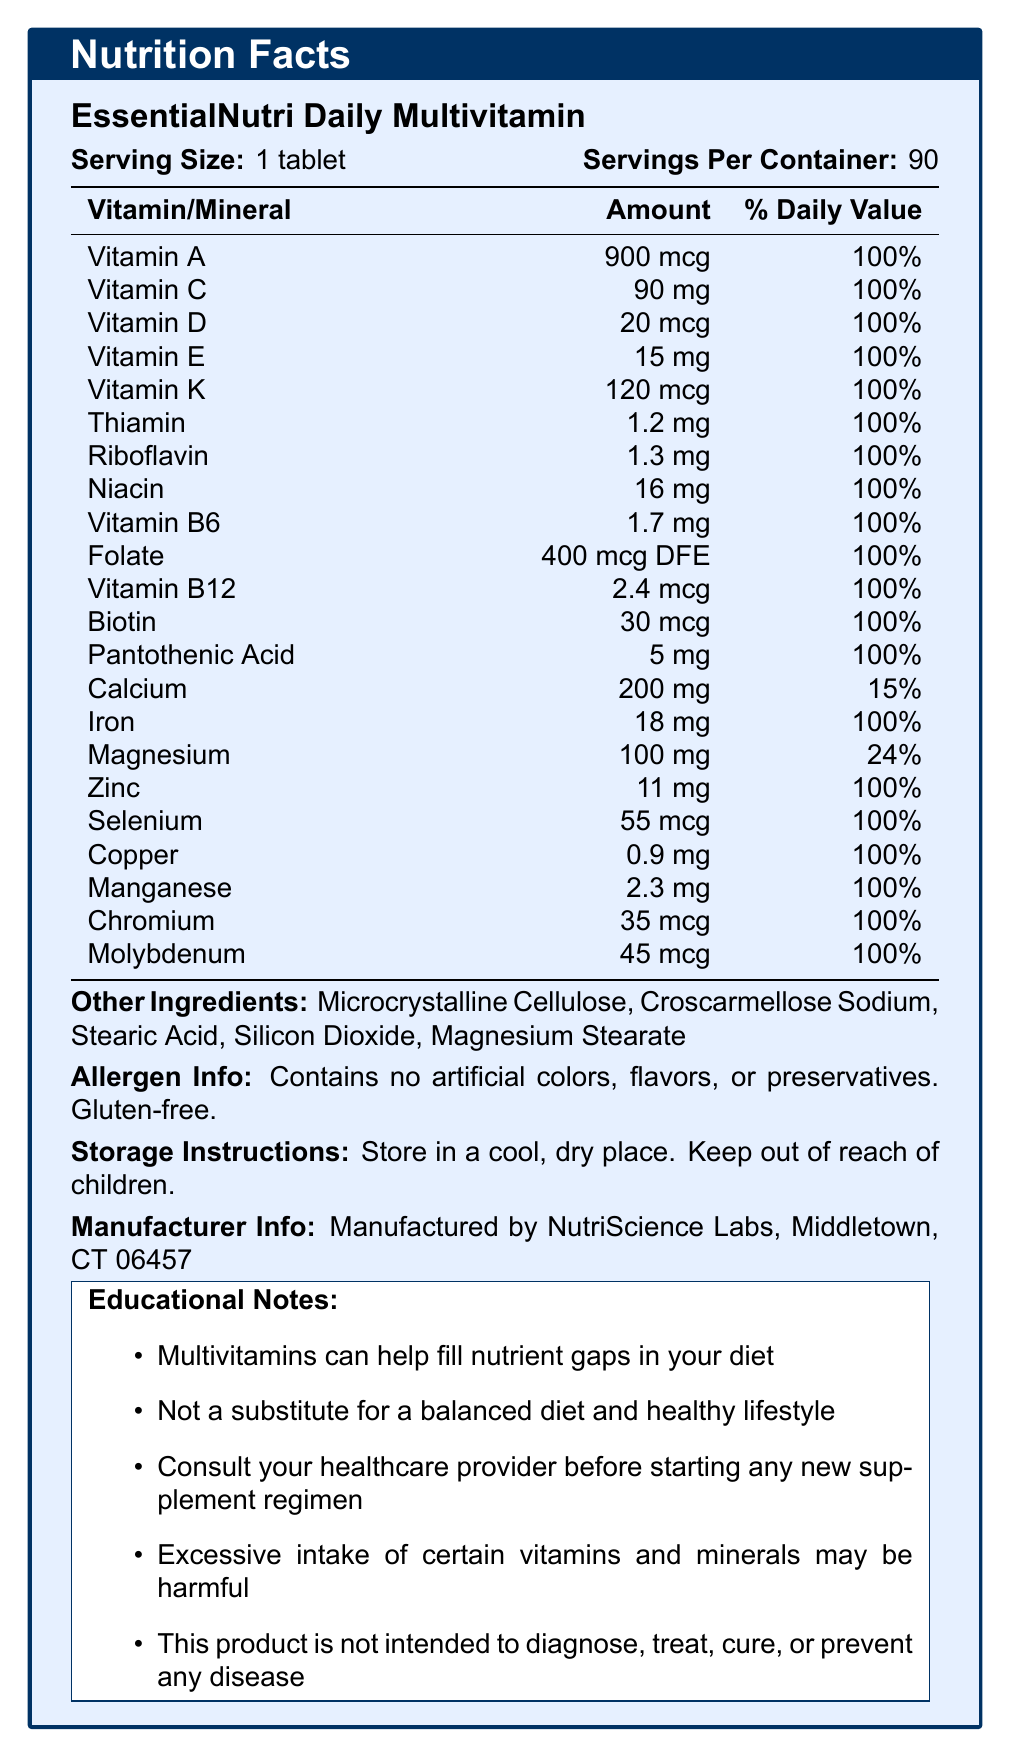What is the serving size for EssentialNutri Daily Multivitamin? The document states the serving size as "1 tablet".
Answer: 1 tablet How many servings are there in one container of EssentialNutri Daily Multivitamin? The document indicates that there are 90 servings per container.
Answer: 90 What is the percentage of the Daily Value for Vitamin C in one tablet of EssentialNutri Daily Multivitamin? The document lists the percentage of the Daily Value for Vitamin C as 100%.
Answer: 100% What is the amount of Iron in one tablet of EssentialNutri Daily Multivitamin? The document specifies that one tablet contains 18 mg of Iron.
Answer: 18 mg List two other ingredients found in EssentialNutri Daily Multivitamin. The document mentions "Microcrystalline Cellulose" and "Croscarmellose Sodium" under other ingredients.
Answer: Microcrystalline Cellulose, Croscarmellose Sodium Which of the following vitamins has an amount of 900 mcg in one tablet? A. Vitamin C B. Vitamin A C. Vitamin B12 D. Vitamin K The document lists 900 mcg as the amount for Vitamin A.
Answer: B. Vitamin A How much Magnesium does one tablet of EssentialNutri Daily Multivitamin contain? A. 90 mg B. 100 mg C. 50 mg D. 200 mg The document shows that one tablet contains 100 mg of Magnesium.
Answer: B. 100 mg Are there any artificial colors, flavors, or preservatives in EssentialNutri Daily Multivitamin? The document clearly states that the product contains no artificial colors, flavors, or preservatives.
Answer: No Is the multivitamin gluten-free? The document specifies that the multivitamin is gluten-free.
Answer: Yes Summarize the main points of the EssentialNutri Daily Multivitamin Nutrition Facts document. The document is concise and informative, outlining the nutritional content of the multivitamin, its formulation details, and key educational points about using supplements.
Answer: The document provides detailed information about the EssentialNutri Daily Multivitamin, including its serving size (1 tablet), number of servings per container (90), and the amounts and daily values for a comprehensive list of vitamins and minerals it contains. It also includes other ingredients, allergen information, storage instructions, and manufacturer details. Additionally, it offers educational notes about multivitamins. What percentage of the Daily Value for Calcium does one tablet of EssentialNutri Daily Multivitamin provide? The document states that one tablet provides 15% of the Daily Value for Calcium.
Answer: 15% Describe the storage instructions for EssentialNutri Daily Multivitamin. The document specifies these storage instructions.
Answer: Store in a cool, dry place. Keep out of reach of children. Which vitamin is present in the smallest amount in one tablet of EssentialNutri Daily Multivitamin? The document lists 2.4 mcg for Vitamin B12, which is the smallest amount compared to the other vitamins.
Answer: Vitamin B12 (2.4 mcg) Can this multivitamin diagnose, treat, cure, or prevent any disease according to the document? The document states that this product is not intended to diagnose, treat, cure, or prevent any disease.
Answer: No Where is EssentialNutri Daily Multivitamin manufactured? The document provides the manufacturer information, indicating it is manufactured by NutriScience Labs in Middletown, CT.
Answer: Middletown, CT 06457 How does the document recommend ensuring the effectiveness and safety of using the multivitamin? The document advises consulting a healthcare provider to ensure the safe and effective use of the multivitamin.
Answer: Consult your healthcare provider before starting any new supplement regimen. What is the amount of Vitamin D in one tablet of EssentialNutri Daily Multivitamin? The document lists the amount of Vitamin D as 20 mcg.
Answer: 20 mcg Does the document give detailed information about the production cost of the multivitamin? The document does not contain any details about the production cost of the multivitamin.
Answer: Not enough information Why is it important to keep EssentialNutri Daily Multivitamin out of reach of children? The document includes this storage instruction to ensure the safety and prevent accidental ingestion by children, which could lead to potential harm.
Answer: To prevent accidental ingestion and potential poisoning. 